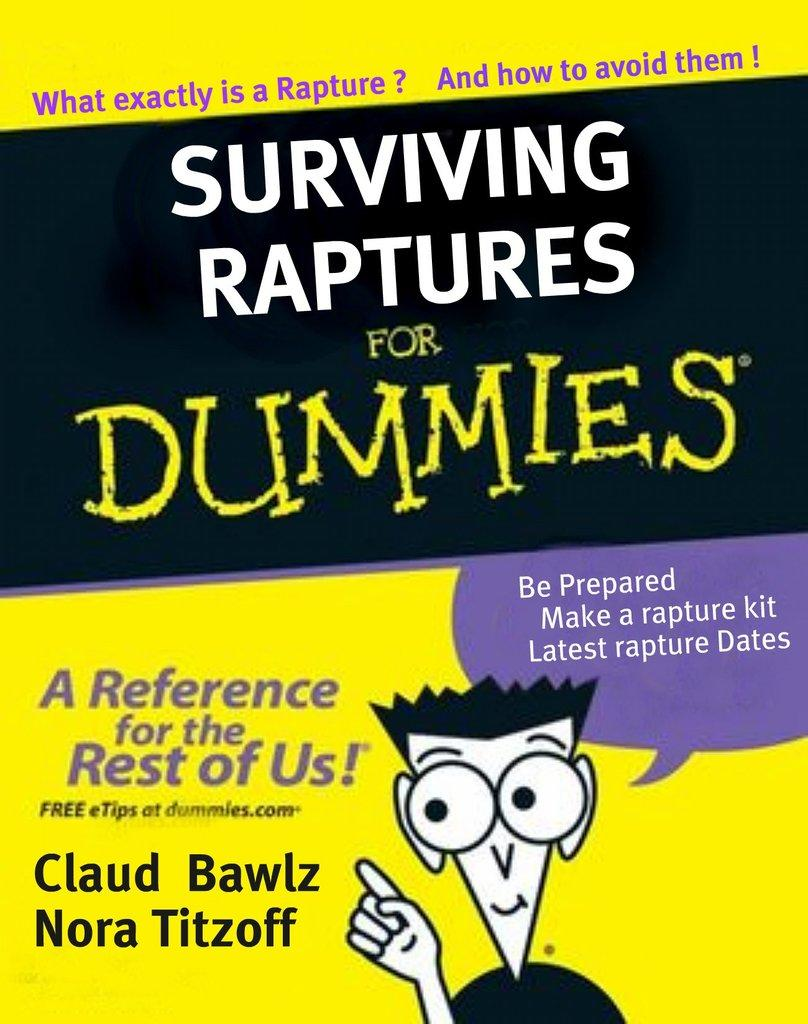<image>
Offer a succinct explanation of the picture presented. Surviving Raptures is one of the books in the Dummies series. 